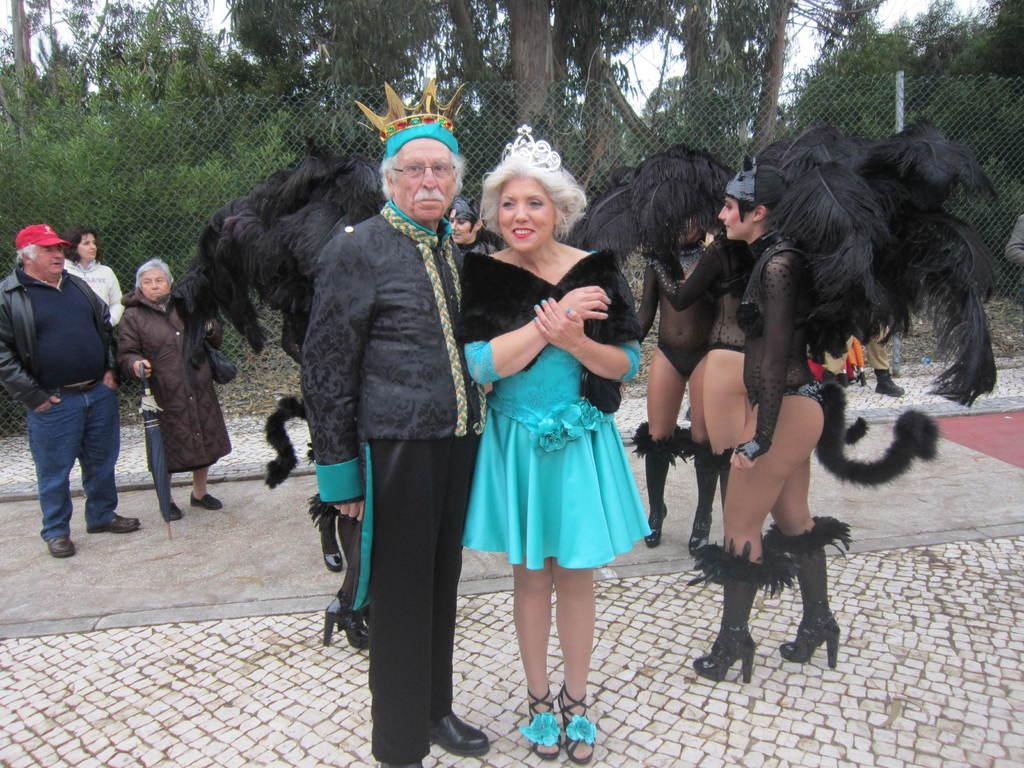Please provide a concise description of this image. In this picture we can see some people are standing, some of them are wearing costumes, there is steel mesh in the middle, in the background there are some trees, we can see the sky at the top of the picture. 